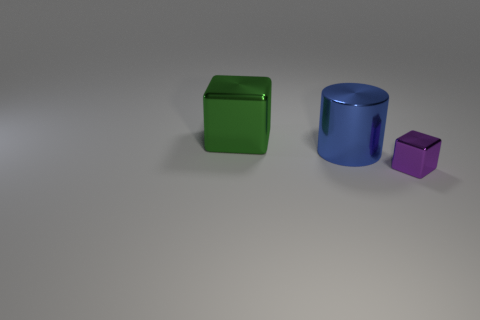Add 3 small purple rubber cylinders. How many objects exist? 6 Subtract all cylinders. How many objects are left? 2 Subtract all small brown cylinders. Subtract all large cubes. How many objects are left? 2 Add 2 purple objects. How many purple objects are left? 3 Add 3 blue metallic objects. How many blue metallic objects exist? 4 Subtract 0 brown blocks. How many objects are left? 3 